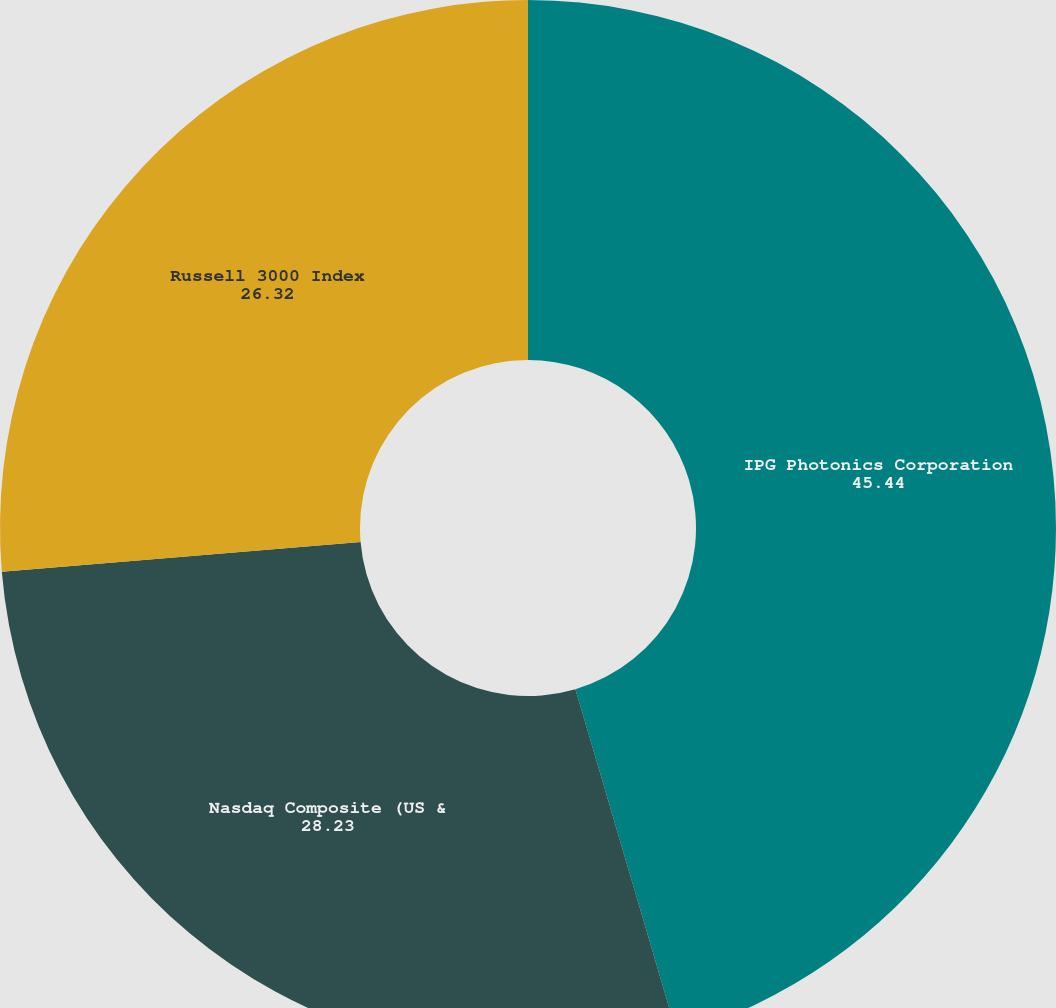<chart> <loc_0><loc_0><loc_500><loc_500><pie_chart><fcel>IPG Photonics Corporation<fcel>Nasdaq Composite (US &<fcel>Russell 3000 Index<nl><fcel>45.44%<fcel>28.23%<fcel>26.32%<nl></chart> 